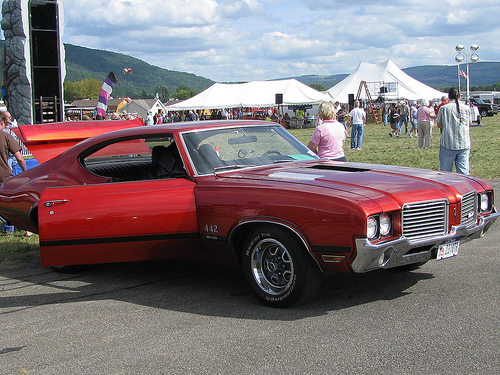<image>
Is the woman behind the car? Yes. From this viewpoint, the woman is positioned behind the car, with the car partially or fully occluding the woman. 